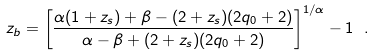<formula> <loc_0><loc_0><loc_500><loc_500>z _ { b } = \left [ \frac { \alpha ( 1 + z _ { s } ) + \beta - ( 2 + z _ { s } ) ( 2 q _ { 0 } + 2 ) } { \alpha - \beta + ( 2 + z _ { s } ) ( 2 q _ { 0 } + 2 ) } \right ] ^ { 1 / \alpha } - 1 \ .</formula> 